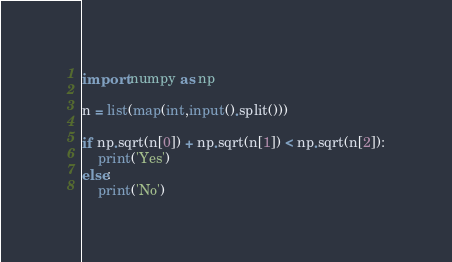<code> <loc_0><loc_0><loc_500><loc_500><_Python_>import numpy as np

n = list(map(int,input().split()))

if np.sqrt(n[0]) + np.sqrt(n[1]) < np.sqrt(n[2]):
    print('Yes')
else:
    print('No')
</code> 